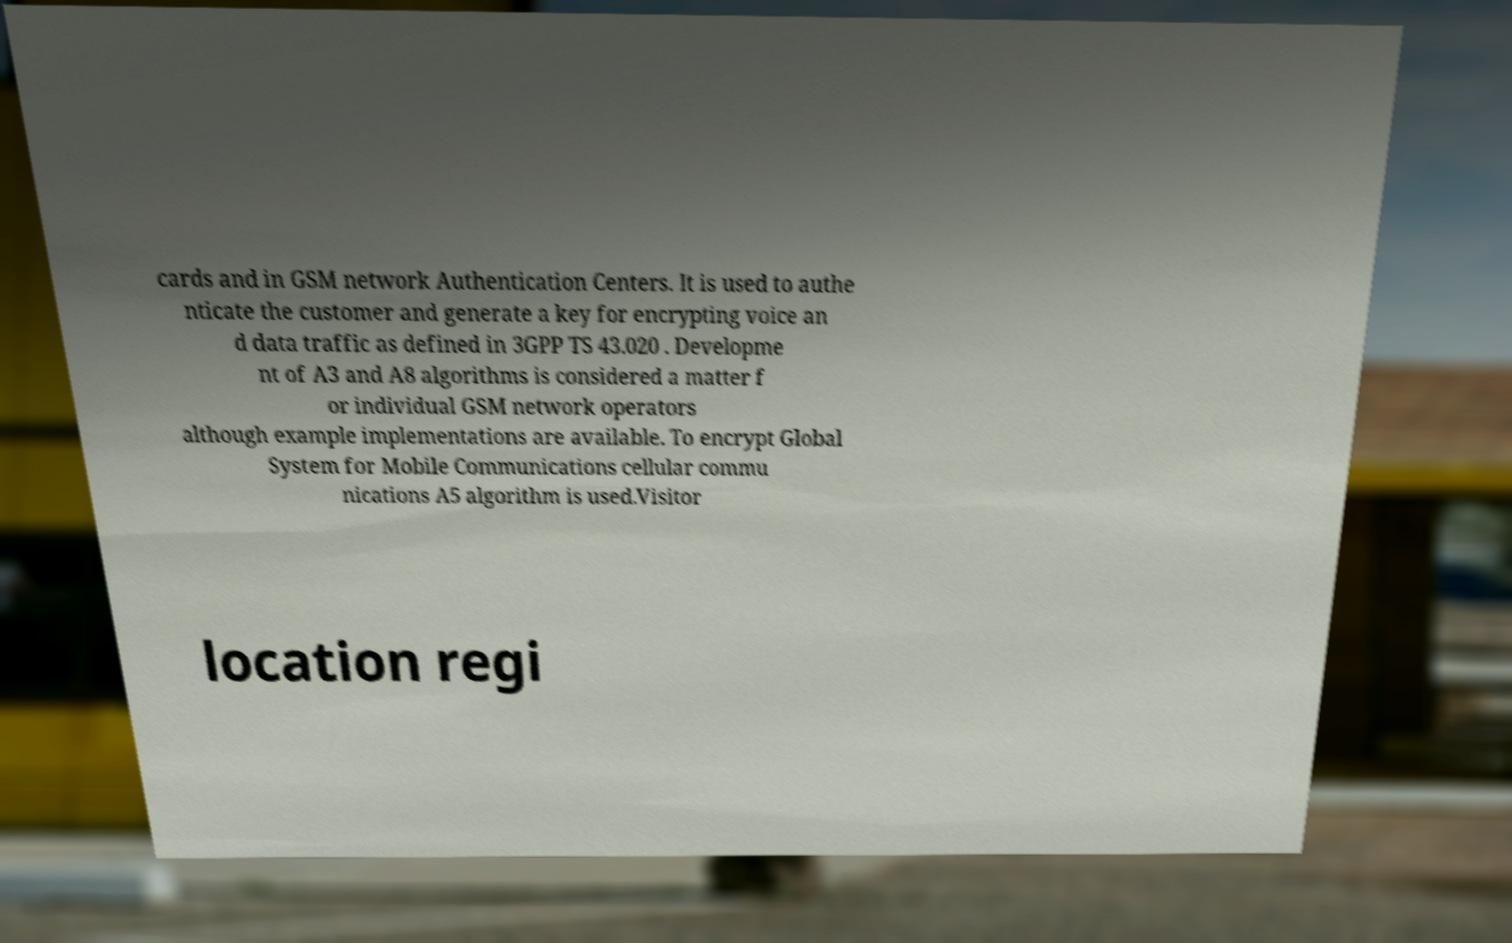Please read and relay the text visible in this image. What does it say? cards and in GSM network Authentication Centers. It is used to authe nticate the customer and generate a key for encrypting voice an d data traffic as defined in 3GPP TS 43.020 . Developme nt of A3 and A8 algorithms is considered a matter f or individual GSM network operators although example implementations are available. To encrypt Global System for Mobile Communications cellular commu nications A5 algorithm is used.Visitor location regi 